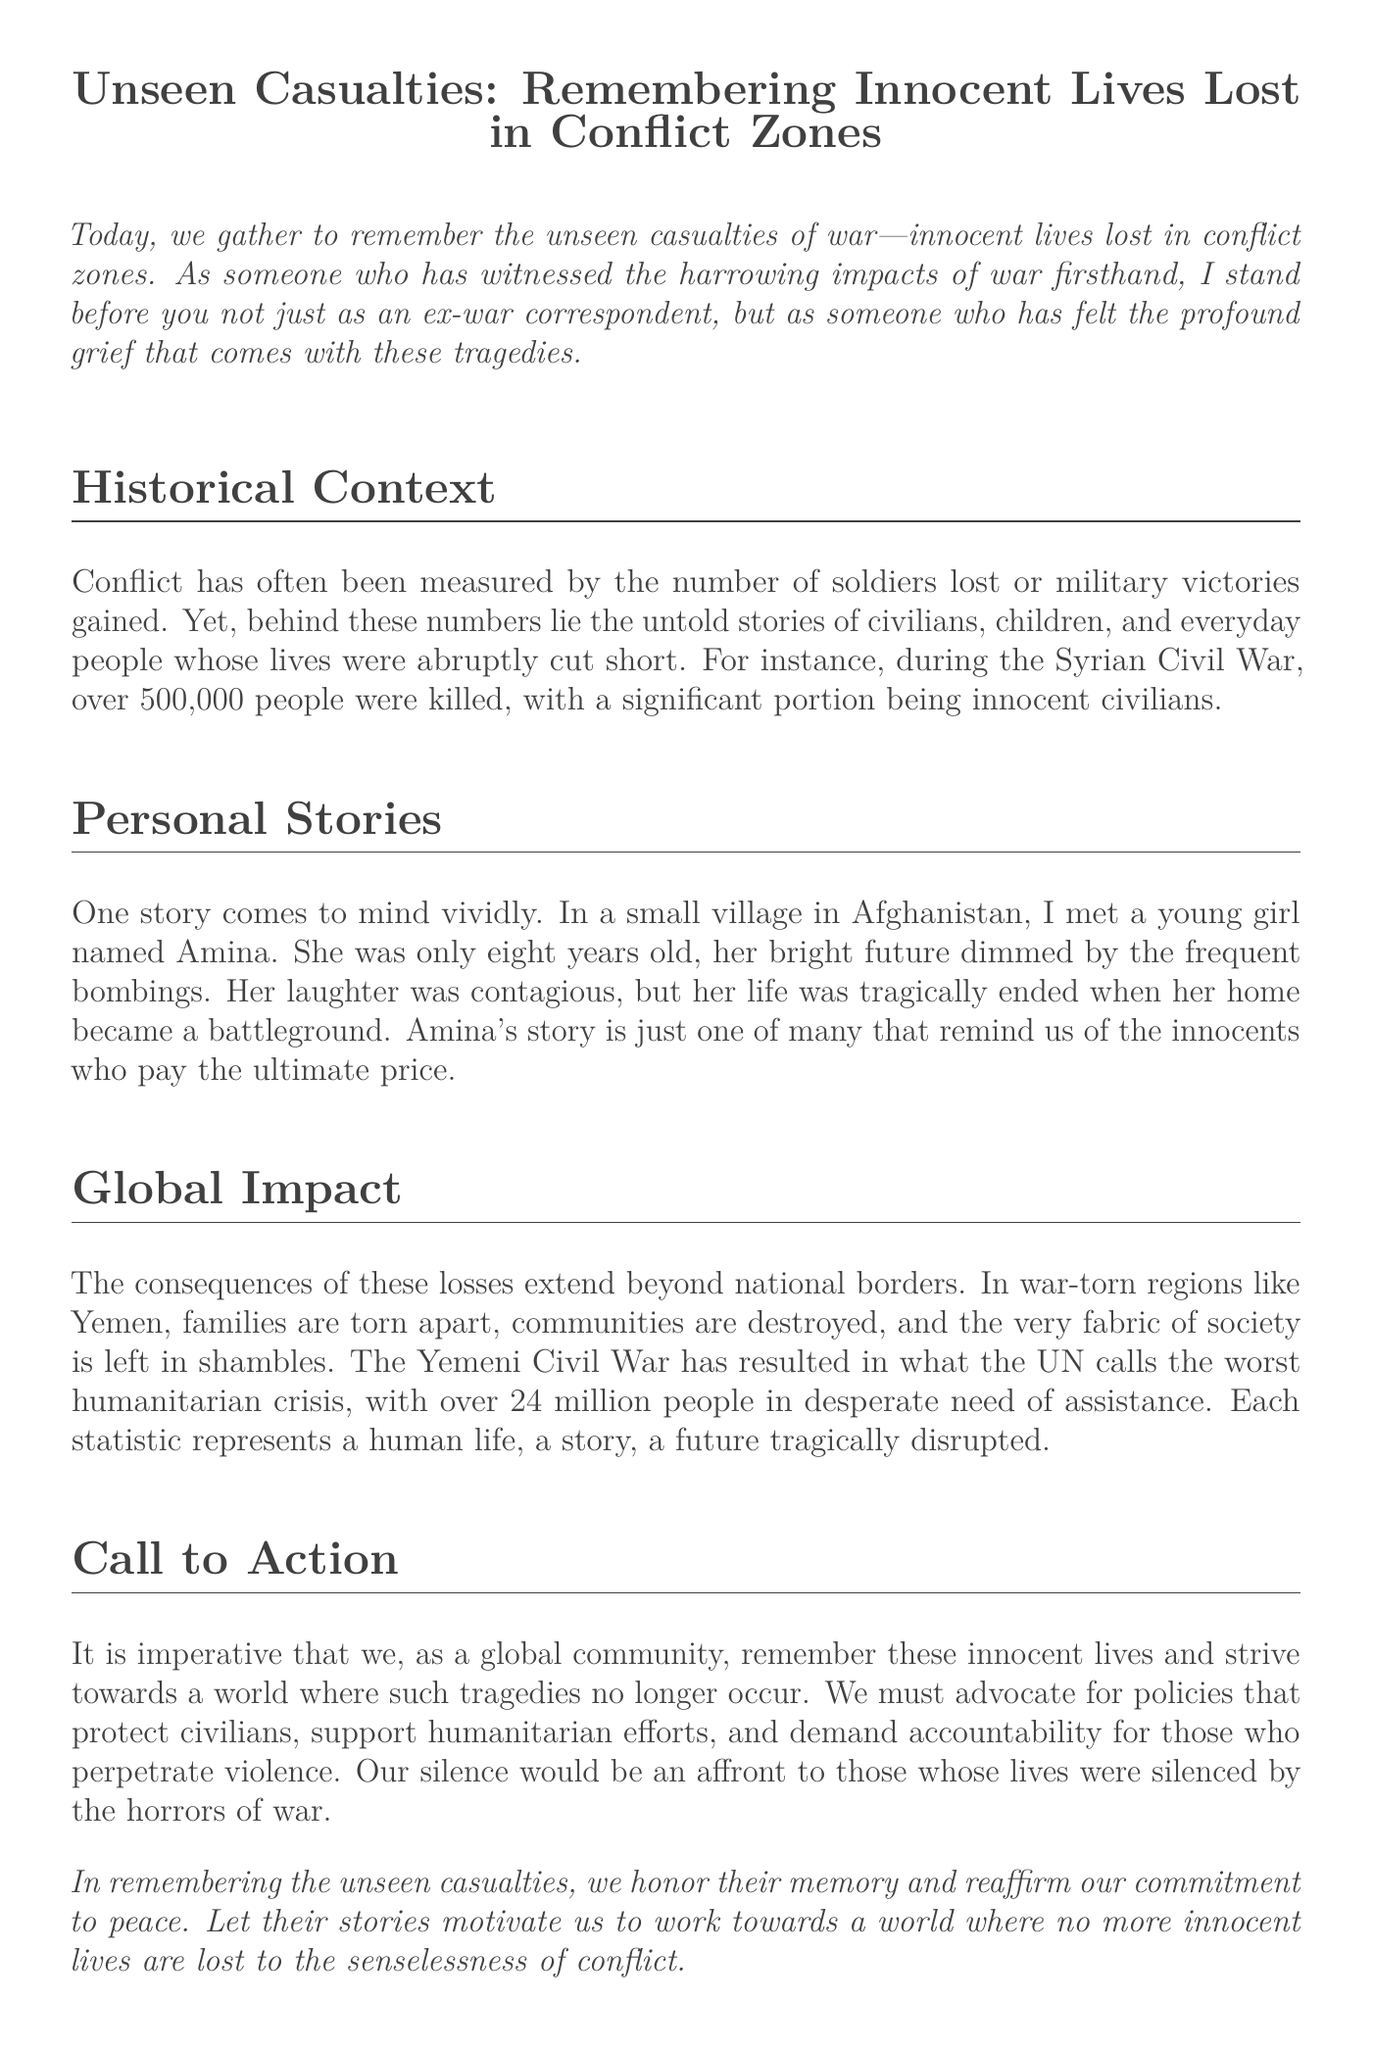what is the title of the document? The title is stated at the beginning of the document, emphasizing the theme of remembering lost lives.
Answer: Unseen Casualties: Remembering Innocent Lives Lost in Conflict Zones how many people were killed during the Syrian Civil War? The document provides a specific figure regarding the casualties of the Syrian Civil War.
Answer: over 500,000 who is mentioned as a young girl in a story? The document narrates a personal story about a specific girl to highlight the impact of war on innocent lives.
Answer: Amina what is described as the worst humanitarian crisis by the UN? The document identifies a specific conflict zone and relates it to a severe humanitarian situation.
Answer: Yemeni Civil War how many people in Yemen are in desperate need of assistance? The document mentions a specific number related to those needing help in Yemen.
Answer: over 24 million what should we strive towards according to the call to action? The document urges readers to work towards a specific goal concerning conflict.
Answer: a world where such tragedies no longer occur which age group is mentioned in the story about Amina? The document specifies the age of the girl discussed in the personal story.
Answer: eight years old what type of policies should we advocate for? The document suggests a type of action to protect civilians affected by war.
Answer: policies that protect civilians what is the overarching theme of this eulogy? The main idea is addressed at the end of the document, emphasizing remembrance and commitment.
Answer: honoring memory and reaffirming commitment to peace 